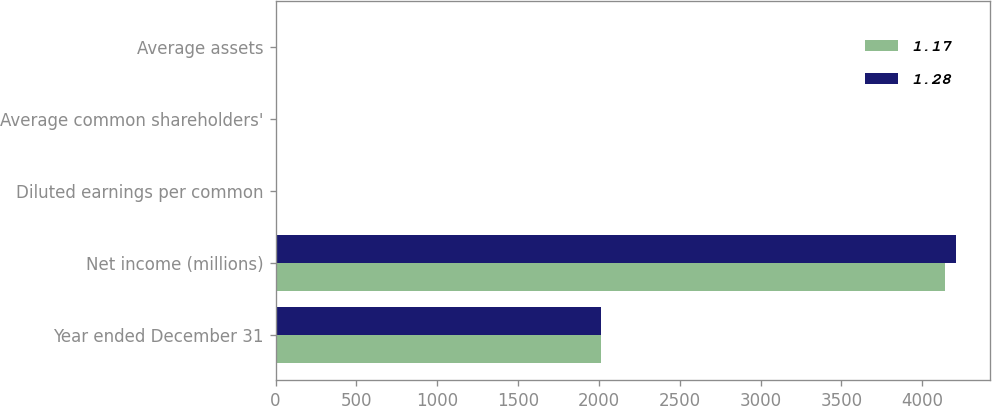<chart> <loc_0><loc_0><loc_500><loc_500><stacked_bar_chart><ecel><fcel>Year ended December 31<fcel>Net income (millions)<fcel>Diluted earnings per common<fcel>Average common shareholders'<fcel>Average assets<nl><fcel>1.17<fcel>2015<fcel>4143<fcel>7.39<fcel>9.5<fcel>1.17<nl><fcel>1.28<fcel>2014<fcel>4207<fcel>7.3<fcel>9.91<fcel>1.28<nl></chart> 